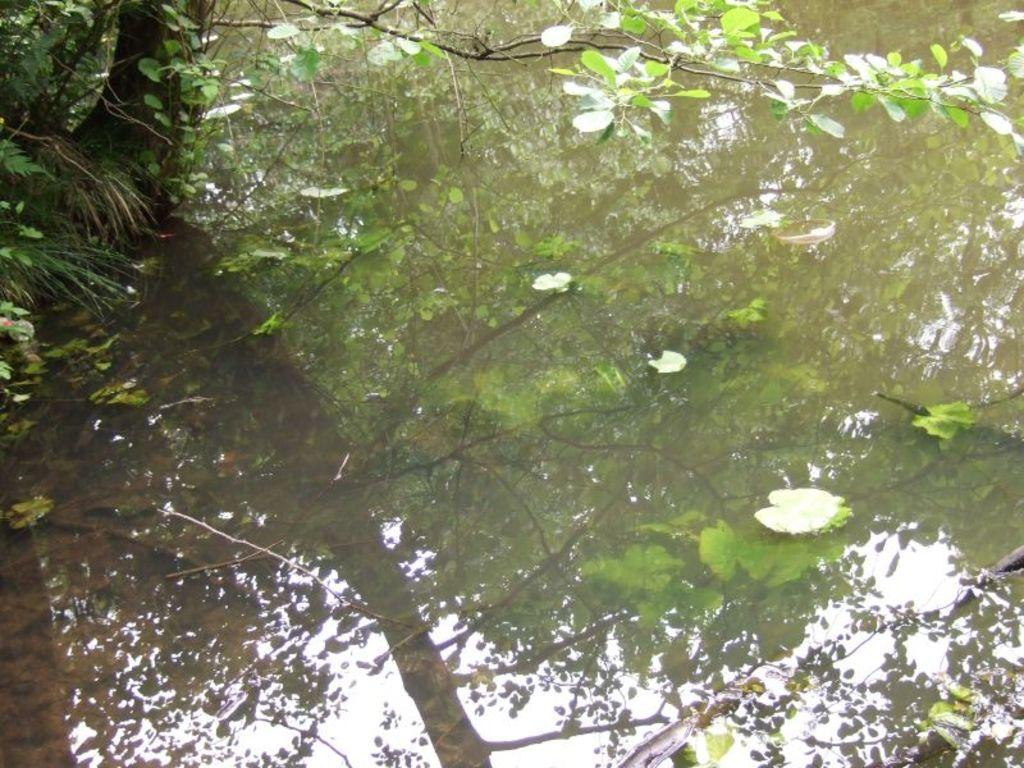What is the primary element visible in the image? There is a water surface in the image. What can be seen reflected on the water surface? A reflection of a tree is visible on the water surface. What type of sound can be heard coming from the quilt in the image? There is no quilt present in the image, so it is not possible to determine what, if any, sound might be heard. 